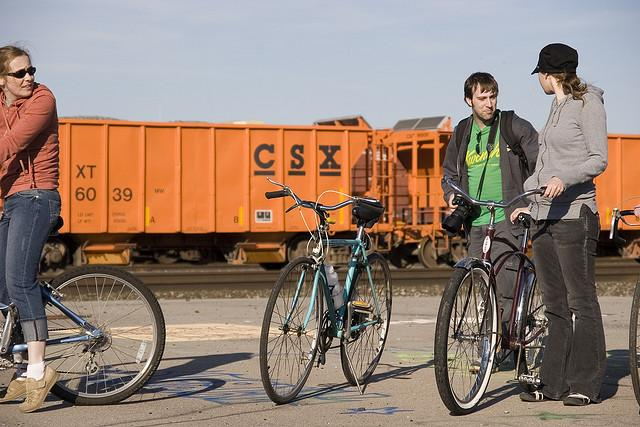How many motors are on the vehicles used by the people shown here to get them here?

Choices:
A) two
B) three
C) three
D) none none 